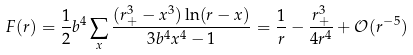Convert formula to latex. <formula><loc_0><loc_0><loc_500><loc_500>F ( r ) = \frac { 1 } { 2 } b ^ { 4 } \sum _ { x } \frac { ( r _ { + } ^ { 3 } - x ^ { 3 } ) \ln ( r - x ) } { 3 b ^ { 4 } x ^ { 4 } - 1 } = \frac { 1 } { r } - \frac { r _ { + } ^ { 3 } } { 4 r ^ { 4 } } + \mathcal { O } ( r ^ { - 5 } )</formula> 